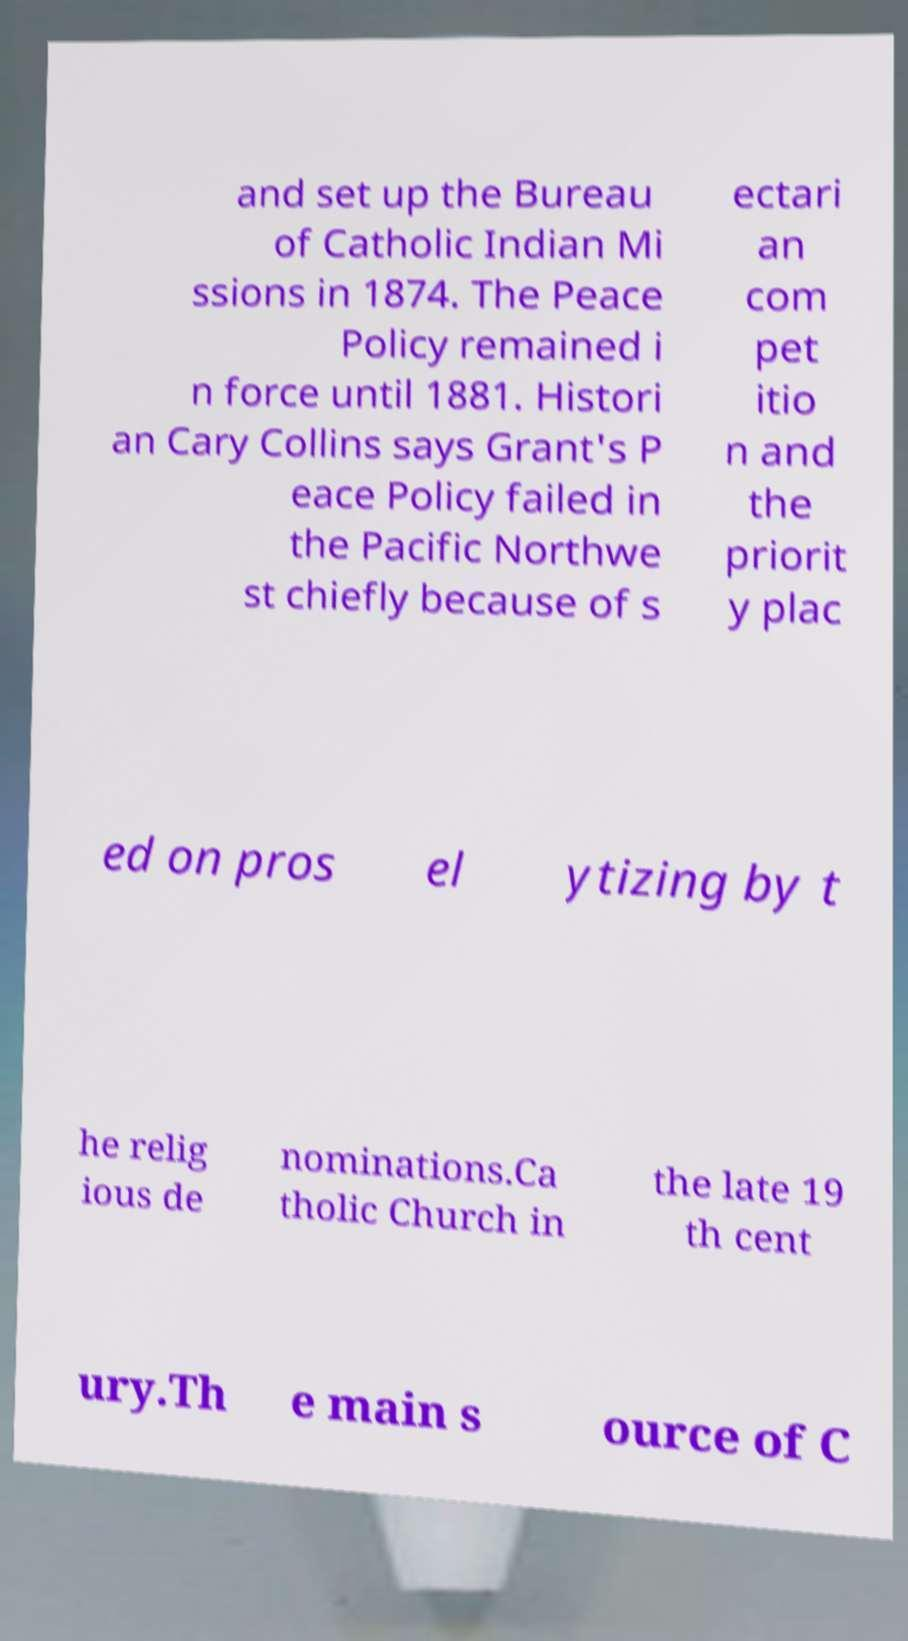I need the written content from this picture converted into text. Can you do that? and set up the Bureau of Catholic Indian Mi ssions in 1874. The Peace Policy remained i n force until 1881. Histori an Cary Collins says Grant's P eace Policy failed in the Pacific Northwe st chiefly because of s ectari an com pet itio n and the priorit y plac ed on pros el ytizing by t he relig ious de nominations.Ca tholic Church in the late 19 th cent ury.Th e main s ource of C 